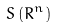<formula> <loc_0><loc_0><loc_500><loc_500>S \left ( R ^ { n } \right )</formula> 